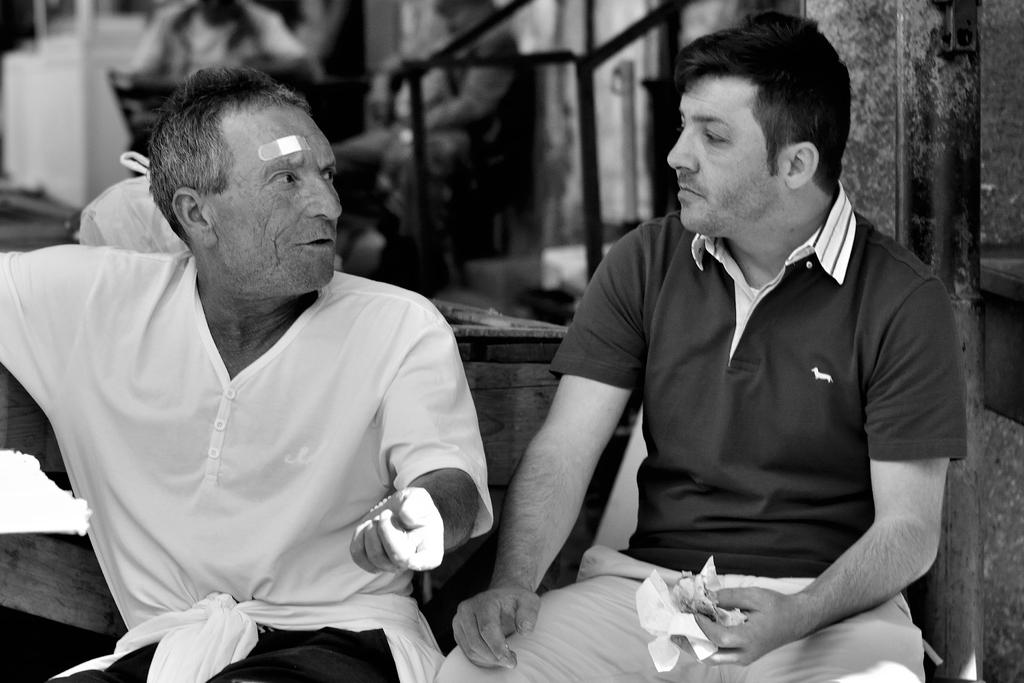How many men are sitting in the image? There are two men sitting in the image. What can be seen in the background of the image? In the background of the image, there are people sitting. What type of straw is being used by the actor in the image? There is no actor or straw present in the image; it only features two men sitting. 